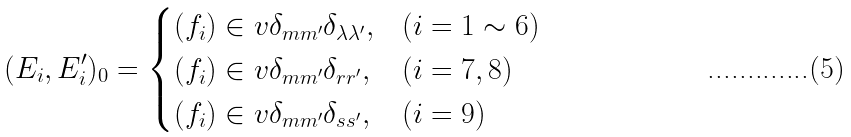Convert formula to latex. <formula><loc_0><loc_0><loc_500><loc_500>( E _ { i } , E _ { i } ^ { \prime } ) _ { 0 } = \begin{cases} ( f _ { i } ) \in v \delta _ { m m ^ { \prime } } \delta _ { \lambda \lambda ^ { \prime } } , & ( i = 1 \sim 6 ) \\ ( f _ { i } ) \in v \delta _ { m m ^ { \prime } } \delta _ { r r ^ { \prime } } , & ( i = 7 , 8 ) \\ ( f _ { i } ) \in v \delta _ { m m ^ { \prime } } \delta _ { s s ^ { \prime } } , & ( i = 9 ) \end{cases}</formula> 